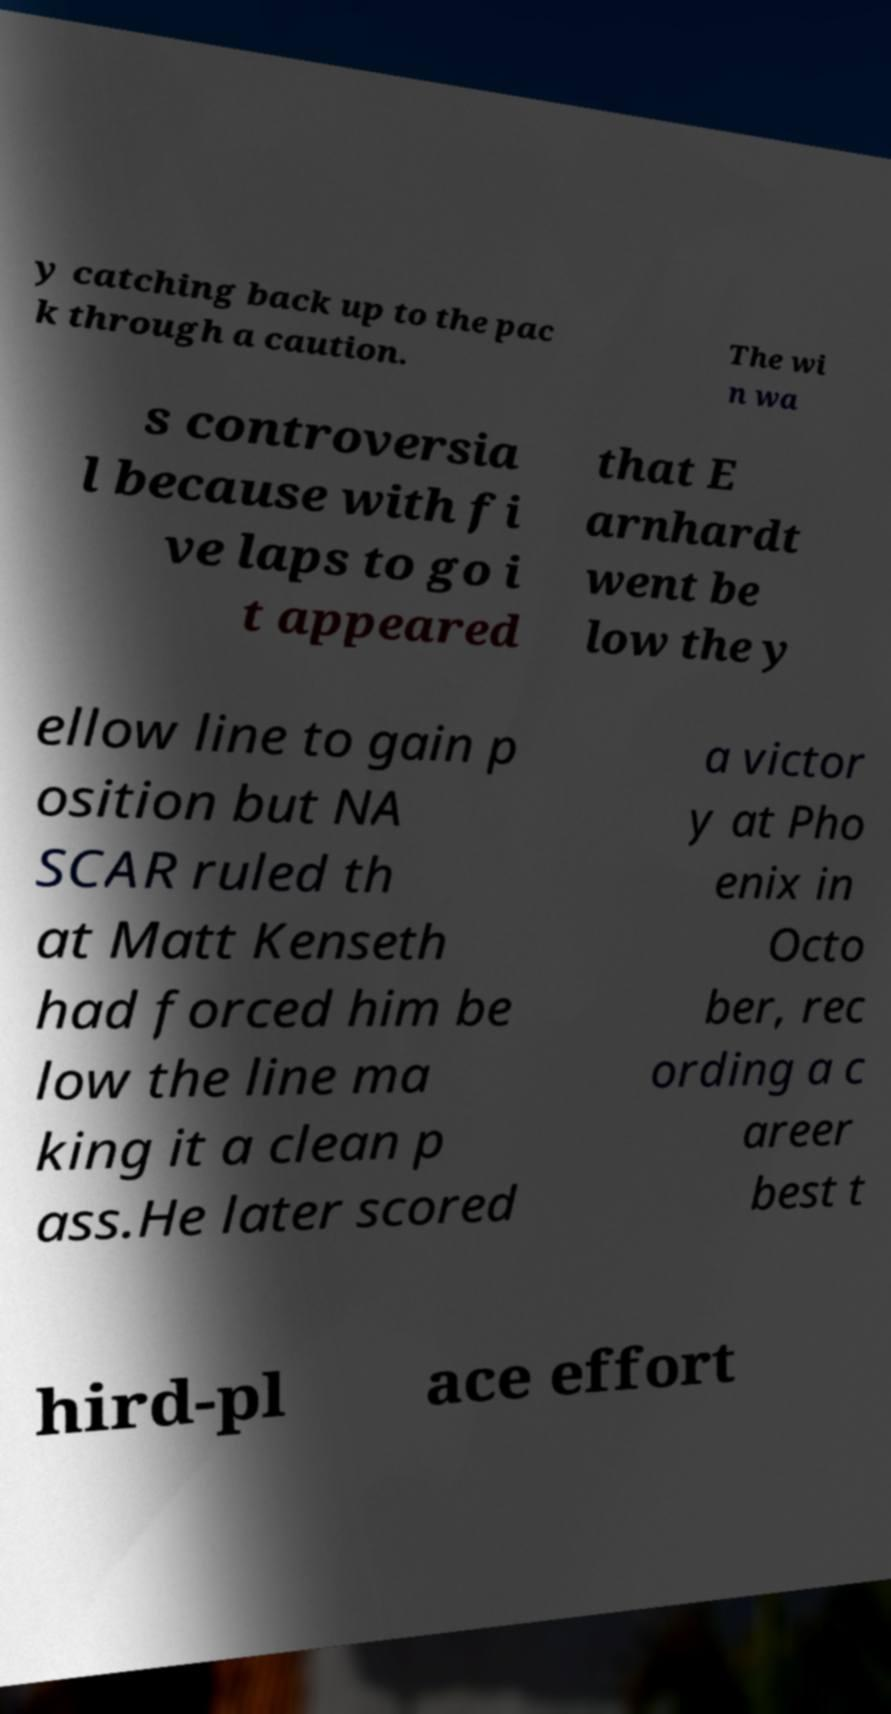I need the written content from this picture converted into text. Can you do that? y catching back up to the pac k through a caution. The wi n wa s controversia l because with fi ve laps to go i t appeared that E arnhardt went be low the y ellow line to gain p osition but NA SCAR ruled th at Matt Kenseth had forced him be low the line ma king it a clean p ass.He later scored a victor y at Pho enix in Octo ber, rec ording a c areer best t hird-pl ace effort 